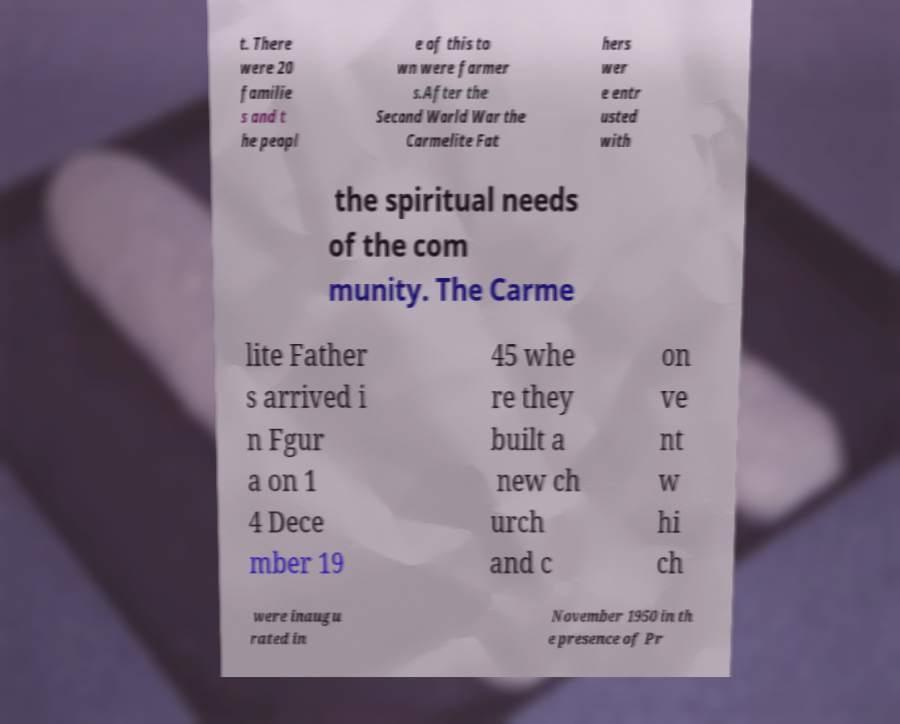What messages or text are displayed in this image? I need them in a readable, typed format. t. There were 20 familie s and t he peopl e of this to wn were farmer s.After the Second World War the Carmelite Fat hers wer e entr usted with the spiritual needs of the com munity. The Carme lite Father s arrived i n Fgur a on 1 4 Dece mber 19 45 whe re they built a new ch urch and c on ve nt w hi ch were inaugu rated in November 1950 in th e presence of Pr 